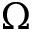<formula> <loc_0><loc_0><loc_500><loc_500>\Omega</formula> 